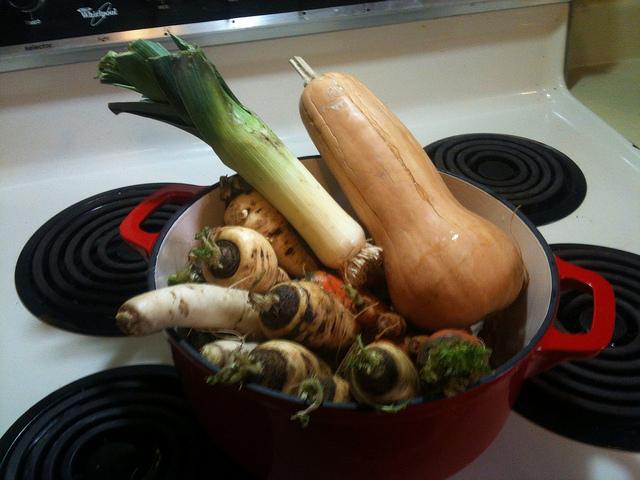What color is the pan?
Write a very short answer. Red. Are the vegetables cooking?
Concise answer only. No. Are these items currently being cooked?
Quick response, please. No. Is this a gas stove?
Write a very short answer. No. Where will cook need to put the pot to cook vegetables?
Short answer required. On burner. 